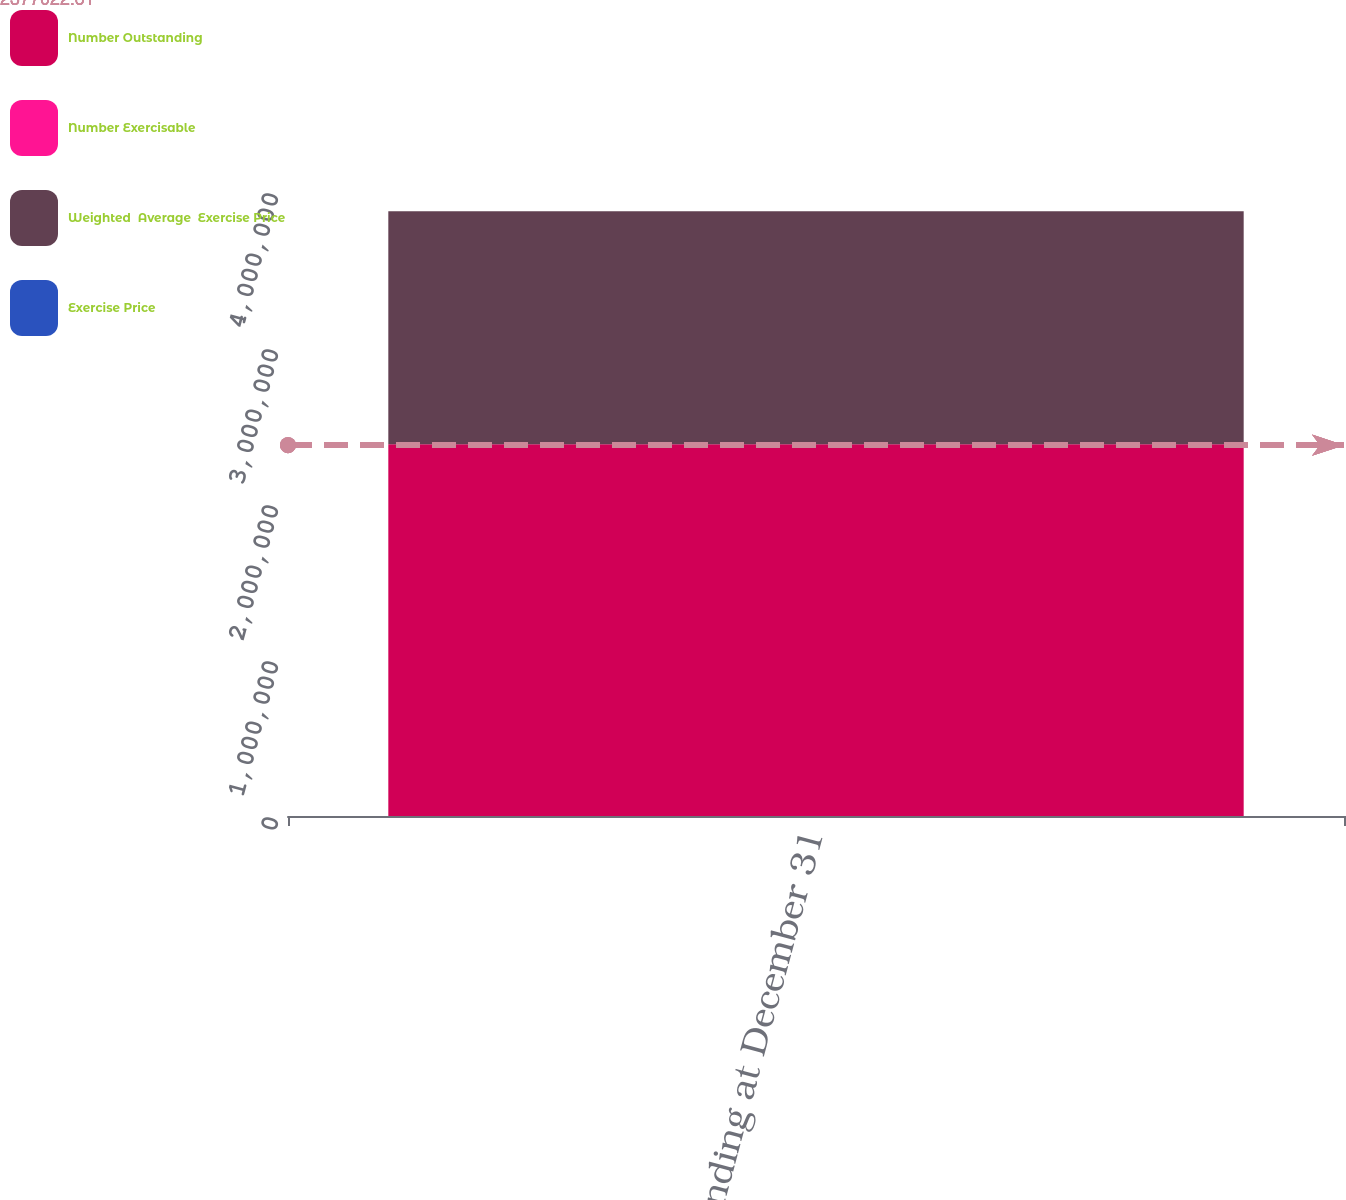<chart> <loc_0><loc_0><loc_500><loc_500><stacked_bar_chart><ecel><fcel>Outstanding at December 31<nl><fcel>Number Outstanding<fcel>2.38324e+06<nl><fcel>Number Exercisable<fcel>35.31<nl><fcel>Weighted  Average  Exercise Price<fcel>1.49282e+06<nl><fcel>Exercise Price<fcel>34.76<nl></chart> 